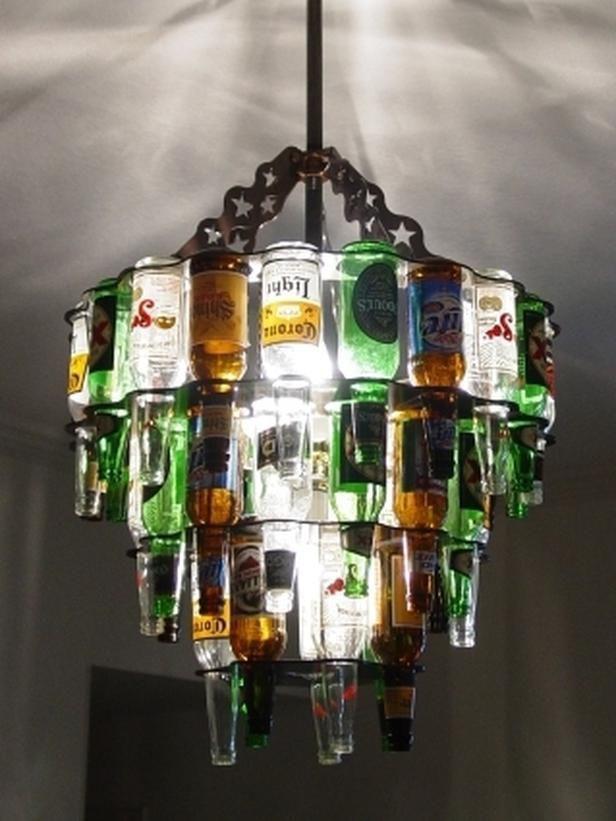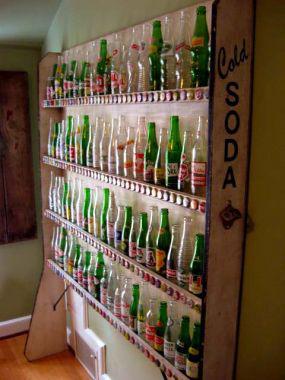The first image is the image on the left, the second image is the image on the right. Evaluate the accuracy of this statement regarding the images: "Dozens of bottles sit on a wall shelf in one of the images.". Is it true? Answer yes or no. Yes. The first image is the image on the left, the second image is the image on the right. Examine the images to the left and right. Is the description "There is a wall of at least four shelves full of glass bottles." accurate? Answer yes or no. Yes. 